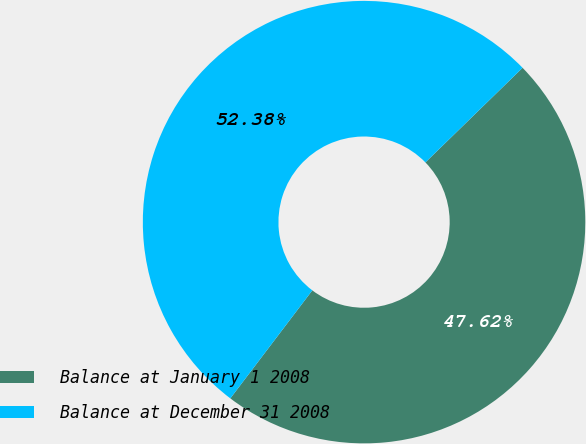Convert chart to OTSL. <chart><loc_0><loc_0><loc_500><loc_500><pie_chart><fcel>Balance at January 1 2008<fcel>Balance at December 31 2008<nl><fcel>47.62%<fcel>52.38%<nl></chart> 